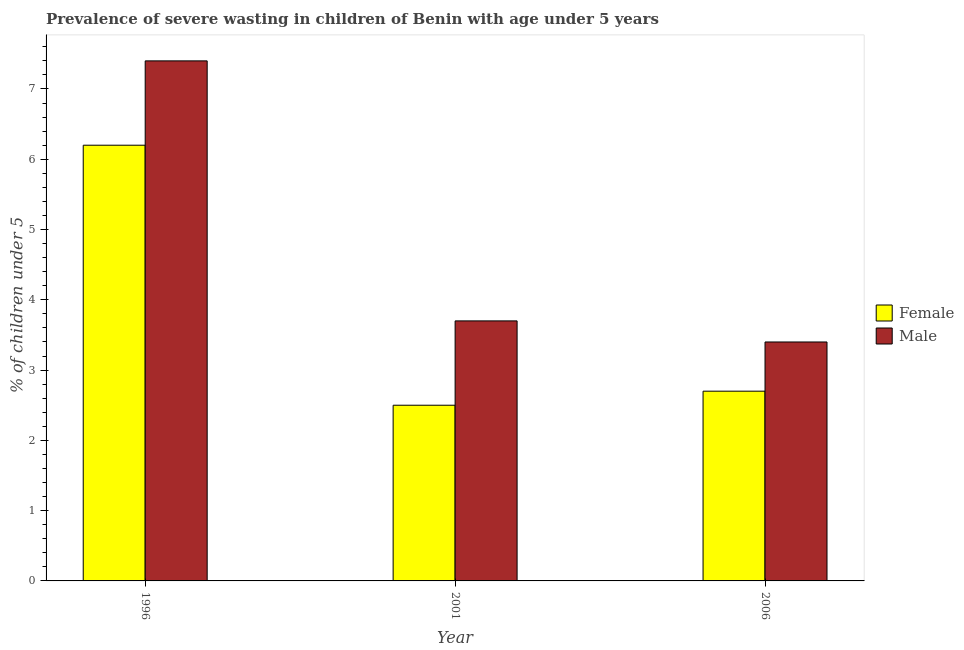How many different coloured bars are there?
Ensure brevity in your answer.  2. How many groups of bars are there?
Make the answer very short. 3. Are the number of bars on each tick of the X-axis equal?
Provide a short and direct response. Yes. What is the label of the 3rd group of bars from the left?
Your answer should be very brief. 2006. In how many cases, is the number of bars for a given year not equal to the number of legend labels?
Provide a short and direct response. 0. What is the percentage of undernourished female children in 1996?
Provide a short and direct response. 6.2. Across all years, what is the maximum percentage of undernourished female children?
Your answer should be compact. 6.2. In which year was the percentage of undernourished female children maximum?
Keep it short and to the point. 1996. What is the total percentage of undernourished male children in the graph?
Give a very brief answer. 14.5. What is the difference between the percentage of undernourished male children in 1996 and that in 2001?
Give a very brief answer. 3.7. What is the difference between the percentage of undernourished female children in 2001 and the percentage of undernourished male children in 1996?
Offer a terse response. -3.7. What is the average percentage of undernourished female children per year?
Ensure brevity in your answer.  3.8. In how many years, is the percentage of undernourished female children greater than 7.2 %?
Provide a succinct answer. 0. What is the ratio of the percentage of undernourished male children in 1996 to that in 2001?
Offer a very short reply. 2. Is the percentage of undernourished male children in 1996 less than that in 2001?
Your response must be concise. No. Is the difference between the percentage of undernourished female children in 1996 and 2001 greater than the difference between the percentage of undernourished male children in 1996 and 2001?
Keep it short and to the point. No. What is the difference between the highest and the second highest percentage of undernourished male children?
Offer a very short reply. 3.7. What is the difference between the highest and the lowest percentage of undernourished female children?
Offer a terse response. 3.7. In how many years, is the percentage of undernourished male children greater than the average percentage of undernourished male children taken over all years?
Your answer should be compact. 1. What does the 2nd bar from the right in 2006 represents?
Ensure brevity in your answer.  Female. How many bars are there?
Offer a very short reply. 6. How many years are there in the graph?
Your answer should be compact. 3. What is the difference between two consecutive major ticks on the Y-axis?
Offer a terse response. 1. Are the values on the major ticks of Y-axis written in scientific E-notation?
Keep it short and to the point. No. Does the graph contain grids?
Keep it short and to the point. No. What is the title of the graph?
Keep it short and to the point. Prevalence of severe wasting in children of Benin with age under 5 years. Does "International Tourists" appear as one of the legend labels in the graph?
Your answer should be compact. No. What is the label or title of the Y-axis?
Keep it short and to the point.  % of children under 5. What is the  % of children under 5 in Female in 1996?
Ensure brevity in your answer.  6.2. What is the  % of children under 5 of Male in 1996?
Provide a short and direct response. 7.4. What is the  % of children under 5 of Male in 2001?
Your answer should be very brief. 3.7. What is the  % of children under 5 of Female in 2006?
Offer a terse response. 2.7. What is the  % of children under 5 of Male in 2006?
Provide a short and direct response. 3.4. Across all years, what is the maximum  % of children under 5 of Female?
Keep it short and to the point. 6.2. Across all years, what is the maximum  % of children under 5 of Male?
Your response must be concise. 7.4. Across all years, what is the minimum  % of children under 5 of Male?
Keep it short and to the point. 3.4. What is the difference between the  % of children under 5 in Male in 1996 and that in 2001?
Make the answer very short. 3.7. What is the difference between the  % of children under 5 in Female in 1996 and that in 2006?
Make the answer very short. 3.5. What is the difference between the  % of children under 5 of Male in 1996 and that in 2006?
Your answer should be compact. 4. What is the difference between the  % of children under 5 of Female in 2001 and that in 2006?
Ensure brevity in your answer.  -0.2. What is the difference between the  % of children under 5 of Male in 2001 and that in 2006?
Ensure brevity in your answer.  0.3. What is the difference between the  % of children under 5 of Female in 1996 and the  % of children under 5 of Male in 2001?
Offer a terse response. 2.5. What is the difference between the  % of children under 5 of Female in 2001 and the  % of children under 5 of Male in 2006?
Your response must be concise. -0.9. What is the average  % of children under 5 of Male per year?
Your answer should be compact. 4.83. In the year 2006, what is the difference between the  % of children under 5 of Female and  % of children under 5 of Male?
Provide a short and direct response. -0.7. What is the ratio of the  % of children under 5 in Female in 1996 to that in 2001?
Ensure brevity in your answer.  2.48. What is the ratio of the  % of children under 5 of Male in 1996 to that in 2001?
Provide a succinct answer. 2. What is the ratio of the  % of children under 5 in Female in 1996 to that in 2006?
Ensure brevity in your answer.  2.3. What is the ratio of the  % of children under 5 in Male in 1996 to that in 2006?
Provide a succinct answer. 2.18. What is the ratio of the  % of children under 5 of Female in 2001 to that in 2006?
Give a very brief answer. 0.93. What is the ratio of the  % of children under 5 of Male in 2001 to that in 2006?
Make the answer very short. 1.09. What is the difference between the highest and the second highest  % of children under 5 in Female?
Keep it short and to the point. 3.5. What is the difference between the highest and the lowest  % of children under 5 in Female?
Keep it short and to the point. 3.7. 